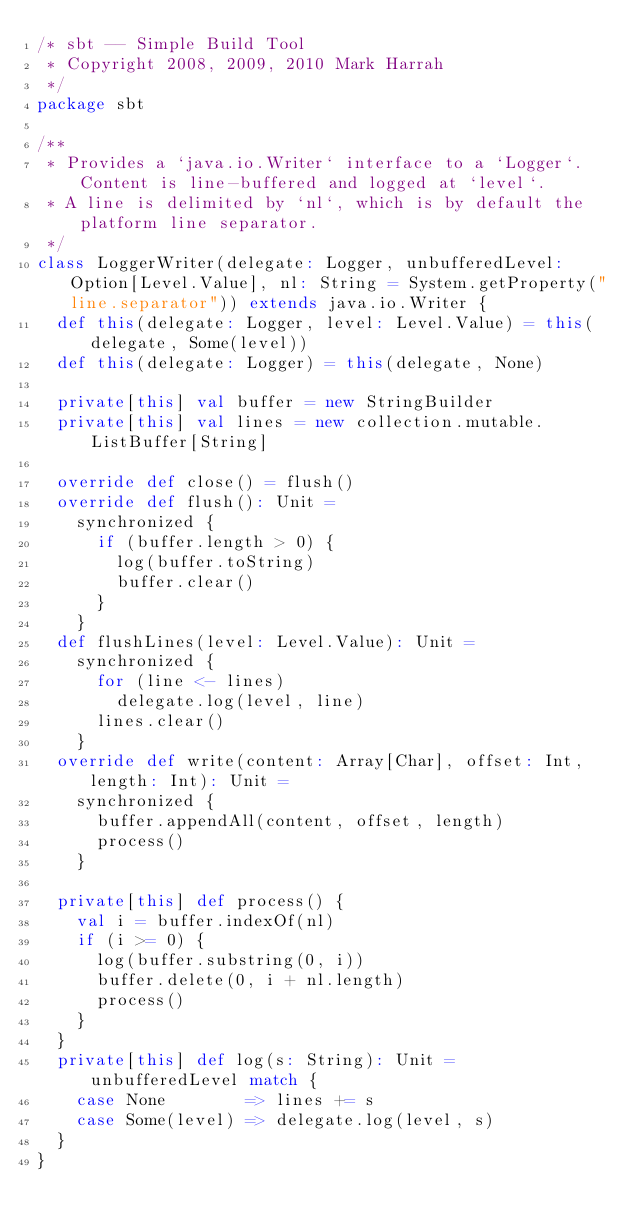Convert code to text. <code><loc_0><loc_0><loc_500><loc_500><_Scala_>/* sbt -- Simple Build Tool
 * Copyright 2008, 2009, 2010 Mark Harrah
 */
package sbt

/**
 * Provides a `java.io.Writer` interface to a `Logger`.  Content is line-buffered and logged at `level`.
 * A line is delimited by `nl`, which is by default the platform line separator.
 */
class LoggerWriter(delegate: Logger, unbufferedLevel: Option[Level.Value], nl: String = System.getProperty("line.separator")) extends java.io.Writer {
  def this(delegate: Logger, level: Level.Value) = this(delegate, Some(level))
  def this(delegate: Logger) = this(delegate, None)

  private[this] val buffer = new StringBuilder
  private[this] val lines = new collection.mutable.ListBuffer[String]

  override def close() = flush()
  override def flush(): Unit =
    synchronized {
      if (buffer.length > 0) {
        log(buffer.toString)
        buffer.clear()
      }
    }
  def flushLines(level: Level.Value): Unit =
    synchronized {
      for (line <- lines)
        delegate.log(level, line)
      lines.clear()
    }
  override def write(content: Array[Char], offset: Int, length: Int): Unit =
    synchronized {
      buffer.appendAll(content, offset, length)
      process()
    }

  private[this] def process() {
    val i = buffer.indexOf(nl)
    if (i >= 0) {
      log(buffer.substring(0, i))
      buffer.delete(0, i + nl.length)
      process()
    }
  }
  private[this] def log(s: String): Unit = unbufferedLevel match {
    case None        => lines += s
    case Some(level) => delegate.log(level, s)
  }
}</code> 